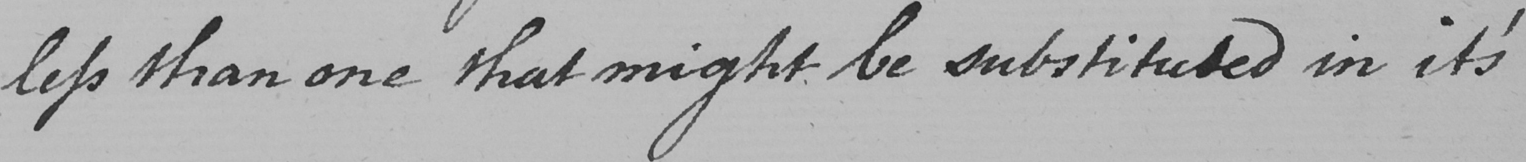What is written in this line of handwriting? less than one might be substituted in it ' s 